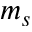<formula> <loc_0><loc_0><loc_500><loc_500>m _ { s }</formula> 